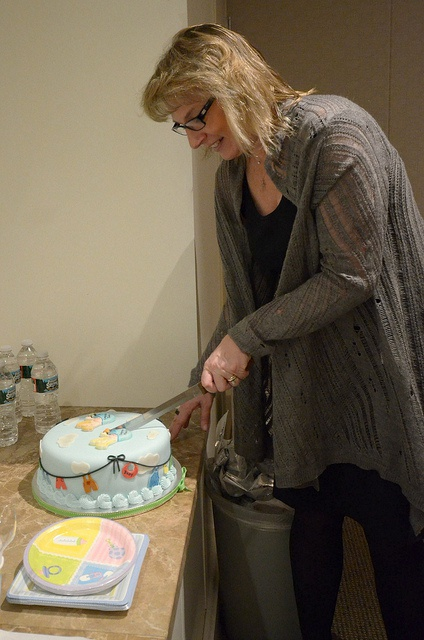Describe the objects in this image and their specific colors. I can see people in gray, black, and maroon tones, dining table in gray, lightgray, tan, darkgray, and olive tones, cake in gray, darkgray, beige, and tan tones, bottle in gray and darkgray tones, and bottle in gray and tan tones in this image. 